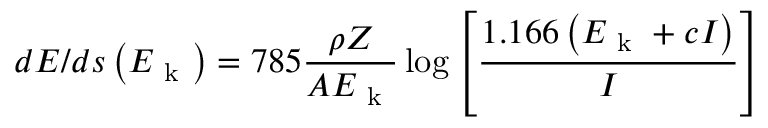<formula> <loc_0><loc_0><loc_500><loc_500>d E / d s \left ( E _ { k } \right ) = 7 8 5 \frac { \rho Z } { A E _ { k } } \log { \left [ \frac { 1 . 1 6 6 \left ( E _ { k } + c I \right ) } { I } \right ] }</formula> 